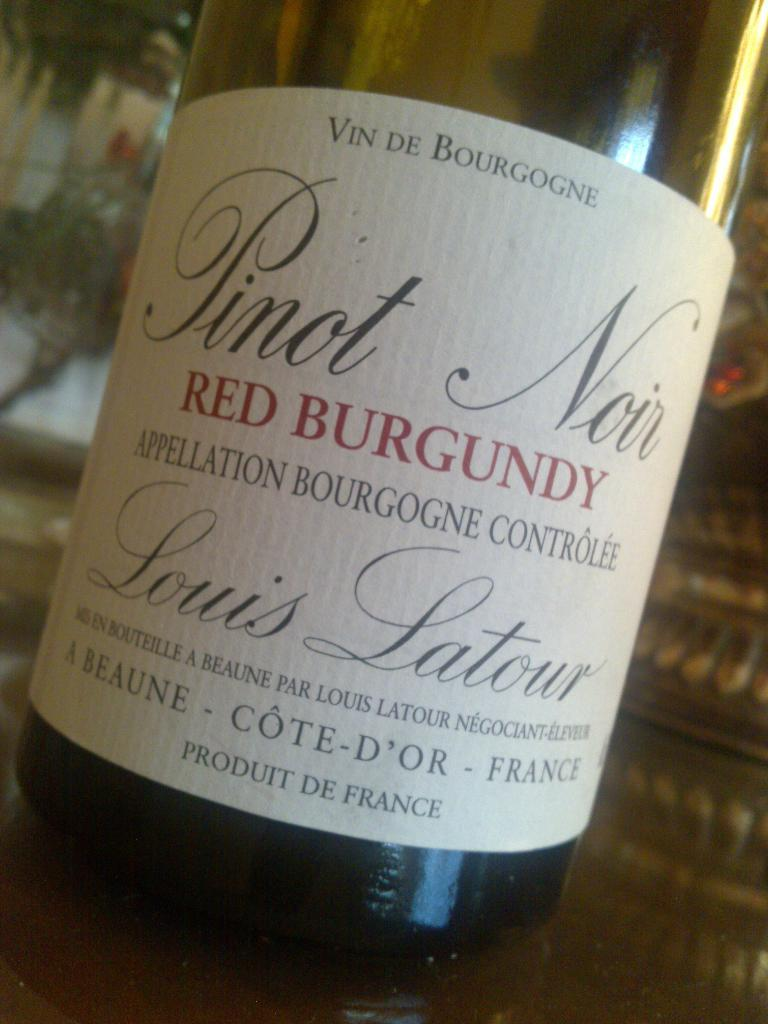Provide a one-sentence caption for the provided image. The bottle of wine is a red Pinot from France. 